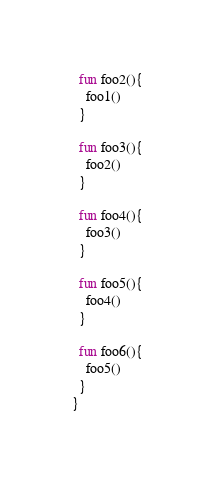<code> <loc_0><loc_0><loc_500><loc_500><_Kotlin_>
  fun foo2(){
    foo1()
  }

  fun foo3(){
    foo2()
  }

  fun foo4(){
    foo3()
  }

  fun foo5(){
    foo4()
  }

  fun foo6(){
    foo5()
  }
}</code> 